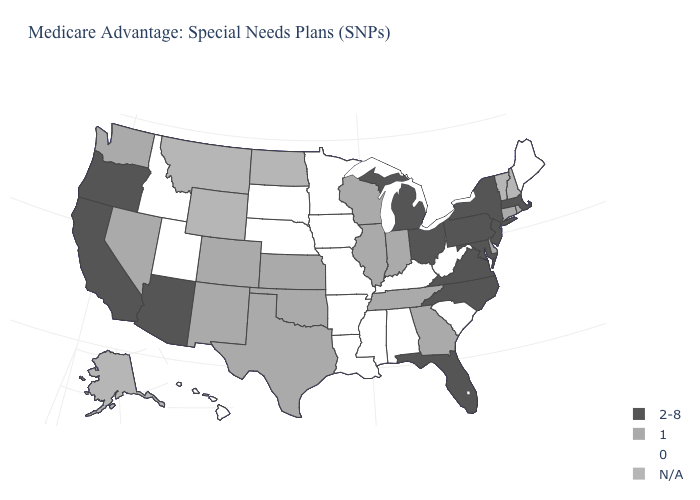What is the value of South Carolina?
Quick response, please. 0. How many symbols are there in the legend?
Answer briefly. 4. Does the map have missing data?
Write a very short answer. Yes. What is the lowest value in the South?
Quick response, please. 0. What is the value of Connecticut?
Write a very short answer. 1. Which states have the lowest value in the MidWest?
Keep it brief. Iowa, Minnesota, Missouri, Nebraska, South Dakota. Which states have the lowest value in the USA?
Write a very short answer. Alabama, Arkansas, Hawaii, Iowa, Idaho, Kentucky, Louisiana, Maine, Minnesota, Missouri, Mississippi, Nebraska, South Carolina, South Dakota, Utah, West Virginia. Does the first symbol in the legend represent the smallest category?
Quick response, please. No. Does Minnesota have the highest value in the USA?
Be succinct. No. What is the value of Vermont?
Give a very brief answer. N/A. Among the states that border North Dakota , which have the lowest value?
Write a very short answer. Minnesota, South Dakota. What is the value of South Dakota?
Concise answer only. 0. Is the legend a continuous bar?
Give a very brief answer. No. 